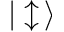Convert formula to latex. <formula><loc_0><loc_0><loc_500><loc_500>| \updownarrow \, \rangle</formula> 